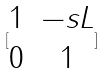<formula> <loc_0><loc_0><loc_500><loc_500>[ \begin{matrix} 1 & - s L \\ 0 & 1 \end{matrix} ]</formula> 